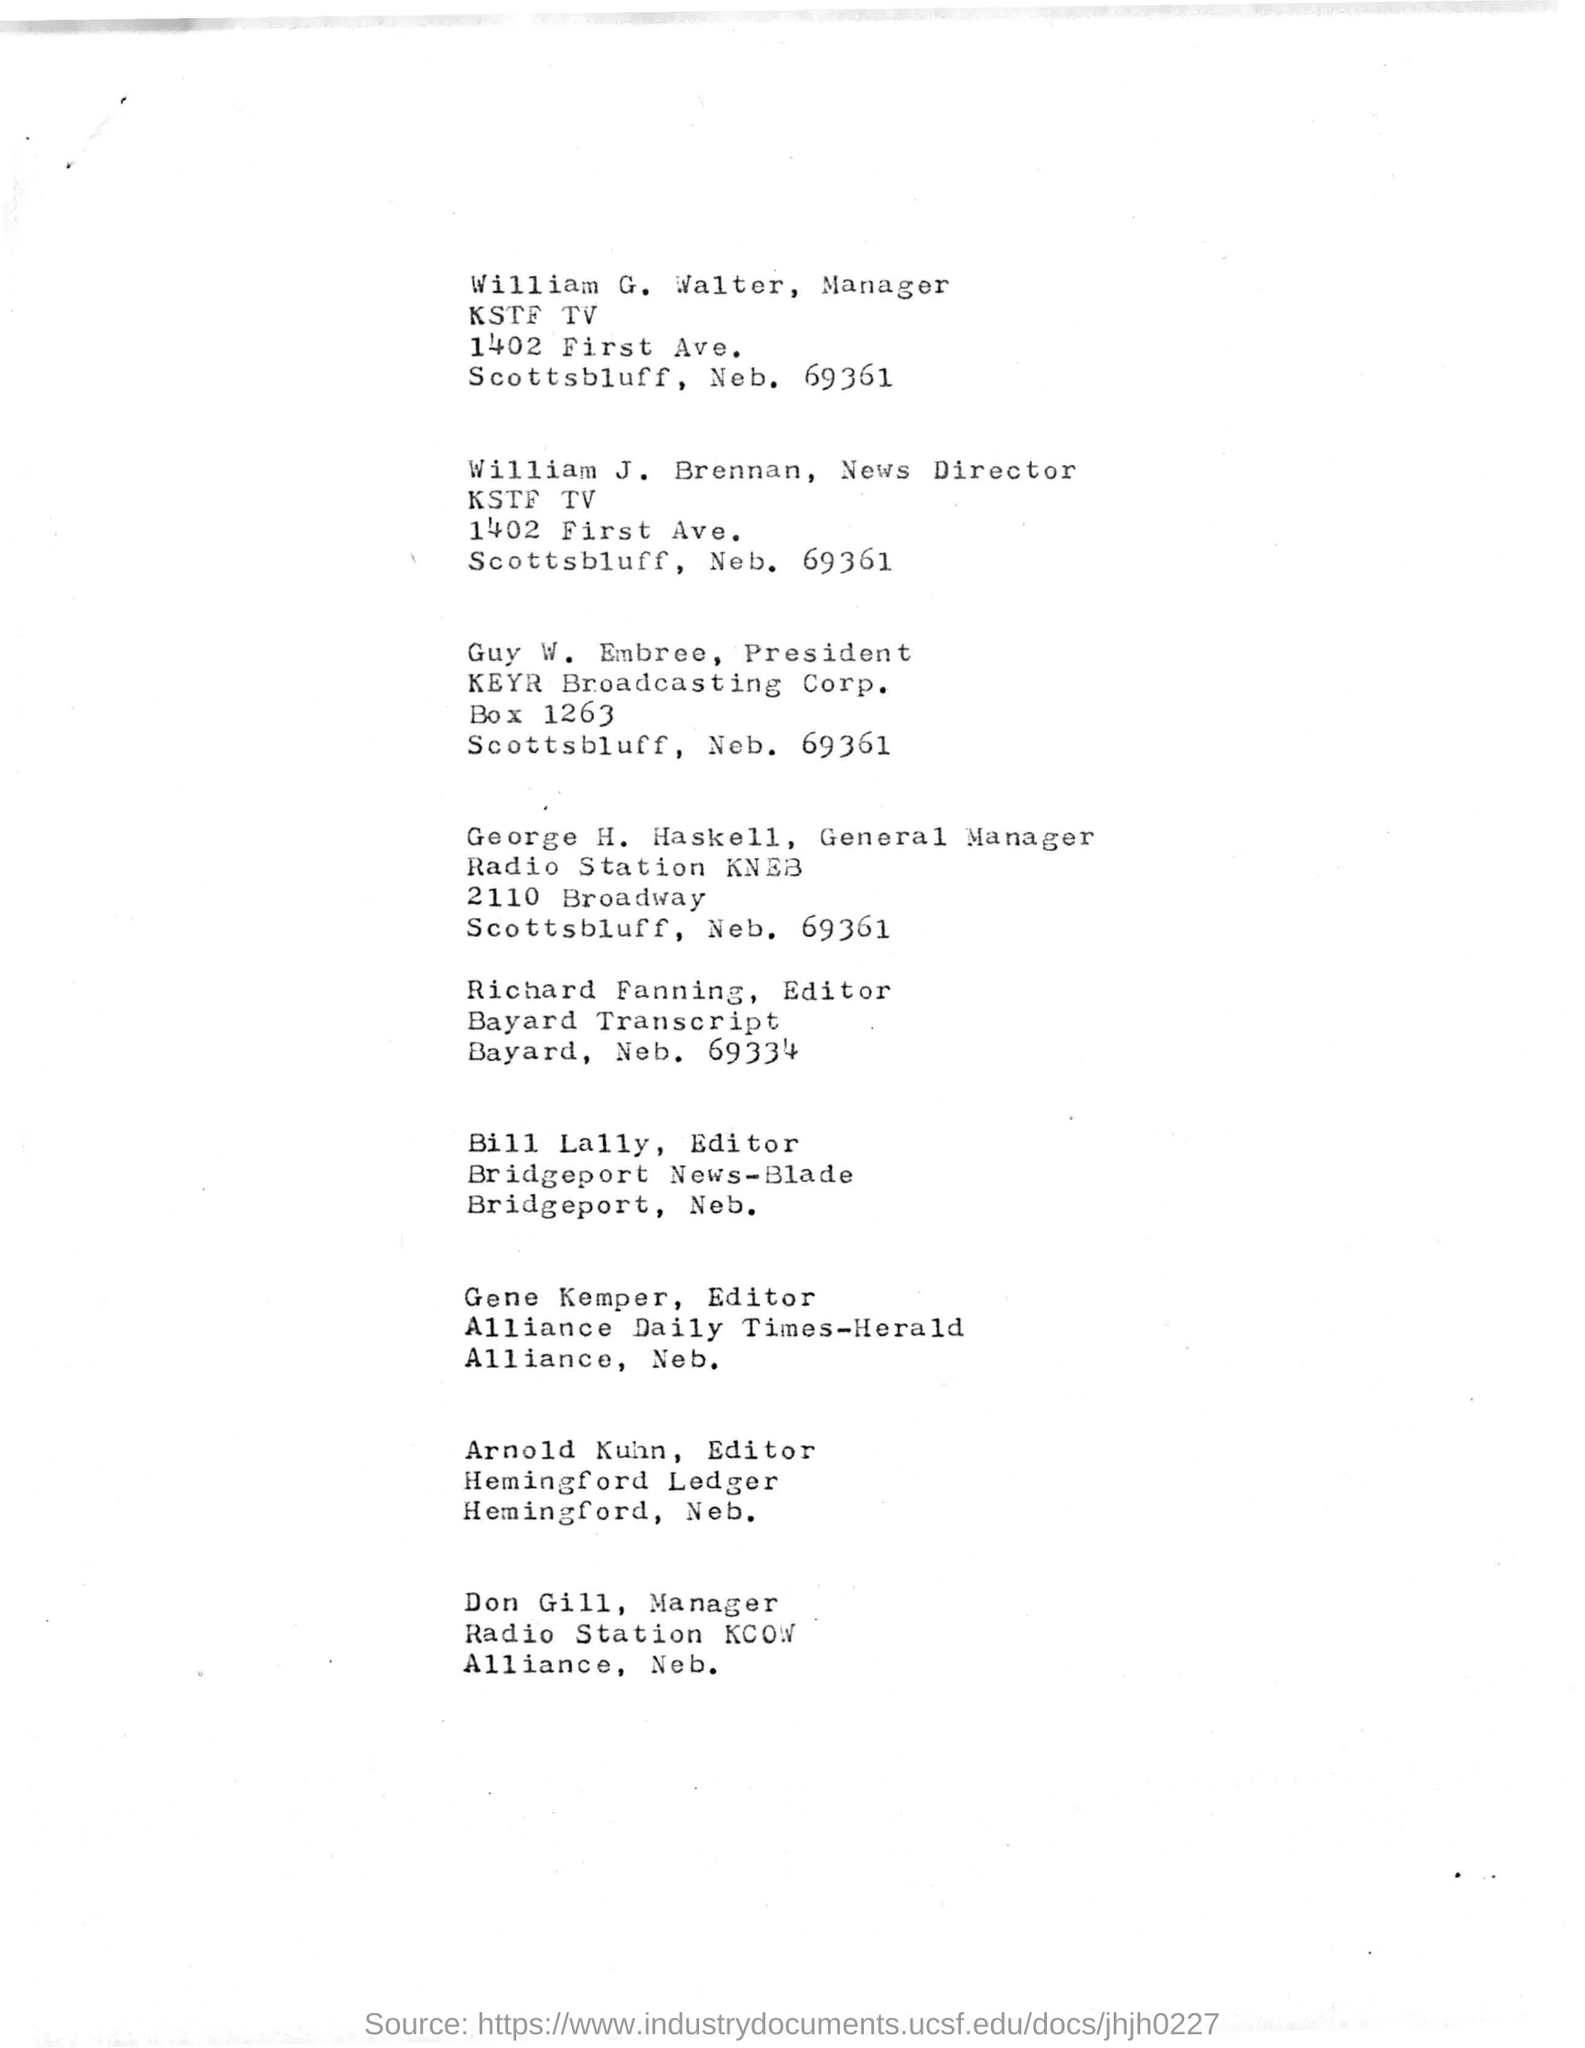Draw attention to some important aspects in this diagram. The manager of KSTF TV is William G Walter. Bill Lally is the editor of Bridgeport News - Blade. 